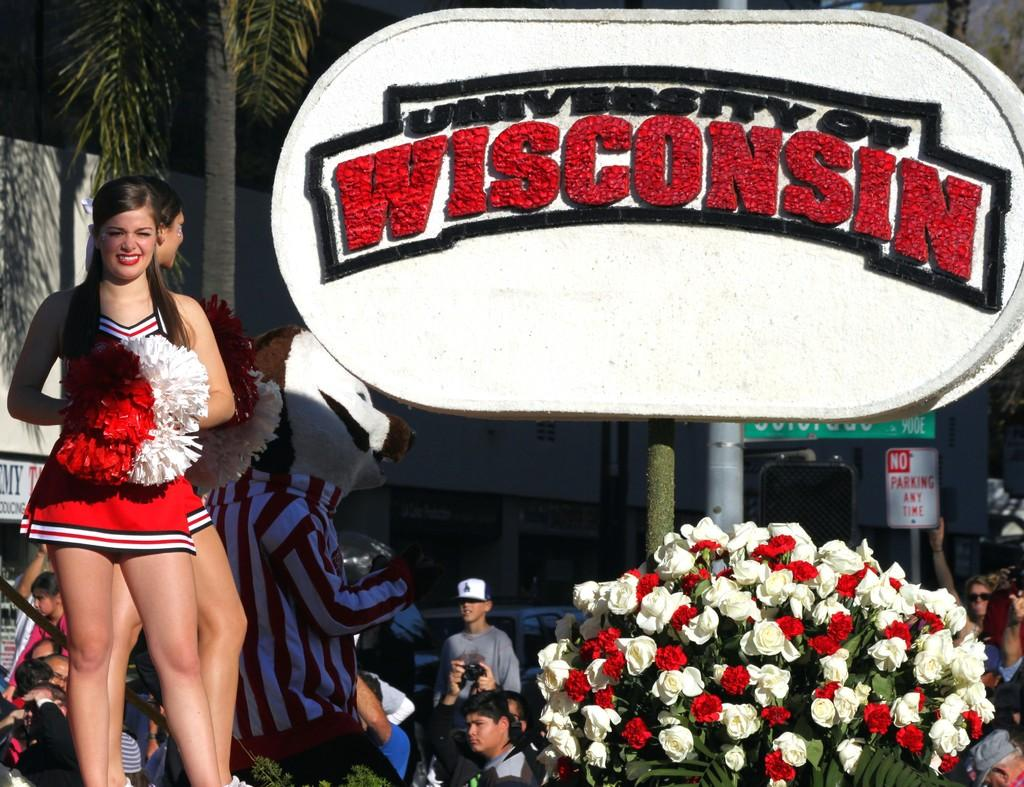<image>
Summarize the visual content of the image. cheerleaders next to bunch of roses and a university of wisconsin sign 